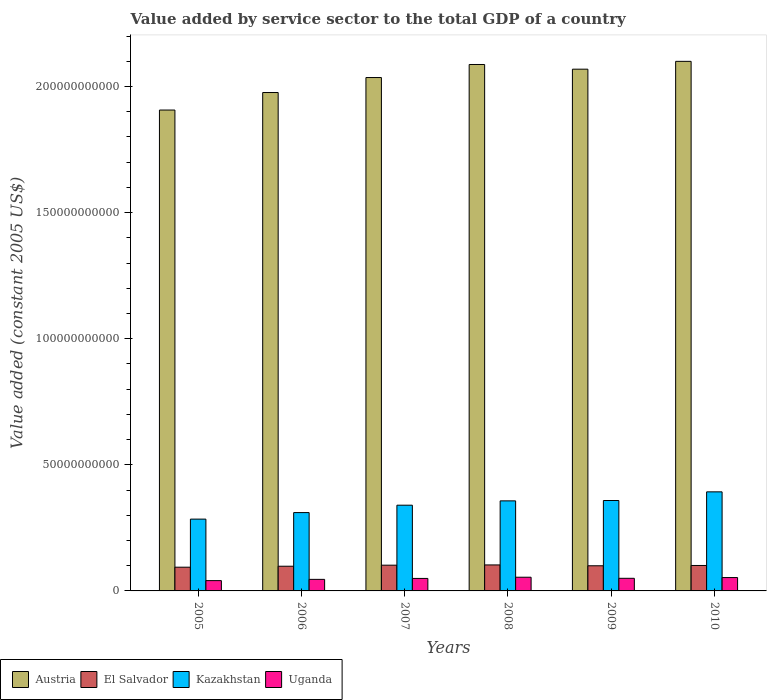What is the value added by service sector in Uganda in 2007?
Give a very brief answer. 4.95e+09. Across all years, what is the maximum value added by service sector in Austria?
Make the answer very short. 2.10e+11. Across all years, what is the minimum value added by service sector in Uganda?
Provide a short and direct response. 4.08e+09. In which year was the value added by service sector in Kazakhstan maximum?
Provide a short and direct response. 2010. What is the total value added by service sector in El Salvador in the graph?
Provide a succinct answer. 5.98e+1. What is the difference between the value added by service sector in Austria in 2005 and that in 2008?
Keep it short and to the point. -1.81e+1. What is the difference between the value added by service sector in El Salvador in 2008 and the value added by service sector in Austria in 2005?
Your answer should be compact. -1.80e+11. What is the average value added by service sector in Austria per year?
Provide a succinct answer. 2.03e+11. In the year 2009, what is the difference between the value added by service sector in El Salvador and value added by service sector in Uganda?
Make the answer very short. 4.97e+09. In how many years, is the value added by service sector in El Salvador greater than 80000000000 US$?
Provide a short and direct response. 0. What is the ratio of the value added by service sector in Kazakhstan in 2008 to that in 2009?
Make the answer very short. 1. What is the difference between the highest and the second highest value added by service sector in Austria?
Offer a very short reply. 1.24e+09. What is the difference between the highest and the lowest value added by service sector in Kazakhstan?
Keep it short and to the point. 1.08e+1. In how many years, is the value added by service sector in El Salvador greater than the average value added by service sector in El Salvador taken over all years?
Give a very brief answer. 4. Is the sum of the value added by service sector in El Salvador in 2007 and 2009 greater than the maximum value added by service sector in Uganda across all years?
Offer a terse response. Yes. What does the 2nd bar from the left in 2010 represents?
Provide a short and direct response. El Salvador. What does the 3rd bar from the right in 2006 represents?
Offer a terse response. El Salvador. Is it the case that in every year, the sum of the value added by service sector in Austria and value added by service sector in El Salvador is greater than the value added by service sector in Uganda?
Your response must be concise. Yes. How many bars are there?
Your answer should be compact. 24. Are all the bars in the graph horizontal?
Make the answer very short. No. Are the values on the major ticks of Y-axis written in scientific E-notation?
Provide a short and direct response. No. Does the graph contain any zero values?
Ensure brevity in your answer.  No. Does the graph contain grids?
Give a very brief answer. No. Where does the legend appear in the graph?
Give a very brief answer. Bottom left. How are the legend labels stacked?
Provide a succinct answer. Horizontal. What is the title of the graph?
Give a very brief answer. Value added by service sector to the total GDP of a country. What is the label or title of the Y-axis?
Your answer should be compact. Value added (constant 2005 US$). What is the Value added (constant 2005 US$) of Austria in 2005?
Offer a very short reply. 1.91e+11. What is the Value added (constant 2005 US$) of El Salvador in 2005?
Your answer should be very brief. 9.41e+09. What is the Value added (constant 2005 US$) of Kazakhstan in 2005?
Ensure brevity in your answer.  2.85e+1. What is the Value added (constant 2005 US$) of Uganda in 2005?
Make the answer very short. 4.08e+09. What is the Value added (constant 2005 US$) of Austria in 2006?
Make the answer very short. 1.98e+11. What is the Value added (constant 2005 US$) of El Salvador in 2006?
Your answer should be very brief. 9.79e+09. What is the Value added (constant 2005 US$) of Kazakhstan in 2006?
Your response must be concise. 3.11e+1. What is the Value added (constant 2005 US$) in Uganda in 2006?
Keep it short and to the point. 4.58e+09. What is the Value added (constant 2005 US$) in Austria in 2007?
Your answer should be very brief. 2.04e+11. What is the Value added (constant 2005 US$) in El Salvador in 2007?
Provide a short and direct response. 1.02e+1. What is the Value added (constant 2005 US$) in Kazakhstan in 2007?
Provide a short and direct response. 3.40e+1. What is the Value added (constant 2005 US$) in Uganda in 2007?
Your answer should be very brief. 4.95e+09. What is the Value added (constant 2005 US$) of Austria in 2008?
Offer a terse response. 2.09e+11. What is the Value added (constant 2005 US$) of El Salvador in 2008?
Provide a short and direct response. 1.03e+1. What is the Value added (constant 2005 US$) in Kazakhstan in 2008?
Your response must be concise. 3.57e+1. What is the Value added (constant 2005 US$) in Uganda in 2008?
Give a very brief answer. 5.43e+09. What is the Value added (constant 2005 US$) in Austria in 2009?
Make the answer very short. 2.07e+11. What is the Value added (constant 2005 US$) of El Salvador in 2009?
Keep it short and to the point. 9.97e+09. What is the Value added (constant 2005 US$) of Kazakhstan in 2009?
Provide a short and direct response. 3.58e+1. What is the Value added (constant 2005 US$) in Uganda in 2009?
Provide a succinct answer. 5.00e+09. What is the Value added (constant 2005 US$) of Austria in 2010?
Provide a succinct answer. 2.10e+11. What is the Value added (constant 2005 US$) in El Salvador in 2010?
Offer a very short reply. 1.01e+1. What is the Value added (constant 2005 US$) of Kazakhstan in 2010?
Your answer should be very brief. 3.93e+1. What is the Value added (constant 2005 US$) in Uganda in 2010?
Ensure brevity in your answer.  5.30e+09. Across all years, what is the maximum Value added (constant 2005 US$) in Austria?
Provide a succinct answer. 2.10e+11. Across all years, what is the maximum Value added (constant 2005 US$) in El Salvador?
Offer a terse response. 1.03e+1. Across all years, what is the maximum Value added (constant 2005 US$) in Kazakhstan?
Give a very brief answer. 3.93e+1. Across all years, what is the maximum Value added (constant 2005 US$) in Uganda?
Offer a very short reply. 5.43e+09. Across all years, what is the minimum Value added (constant 2005 US$) of Austria?
Provide a short and direct response. 1.91e+11. Across all years, what is the minimum Value added (constant 2005 US$) in El Salvador?
Your answer should be compact. 9.41e+09. Across all years, what is the minimum Value added (constant 2005 US$) of Kazakhstan?
Give a very brief answer. 2.85e+1. Across all years, what is the minimum Value added (constant 2005 US$) in Uganda?
Your answer should be compact. 4.08e+09. What is the total Value added (constant 2005 US$) of Austria in the graph?
Offer a terse response. 1.22e+12. What is the total Value added (constant 2005 US$) in El Salvador in the graph?
Give a very brief answer. 5.98e+1. What is the total Value added (constant 2005 US$) of Kazakhstan in the graph?
Your response must be concise. 2.04e+11. What is the total Value added (constant 2005 US$) of Uganda in the graph?
Your answer should be compact. 2.93e+1. What is the difference between the Value added (constant 2005 US$) in Austria in 2005 and that in 2006?
Your answer should be compact. -6.94e+09. What is the difference between the Value added (constant 2005 US$) of El Salvador in 2005 and that in 2006?
Ensure brevity in your answer.  -3.86e+08. What is the difference between the Value added (constant 2005 US$) in Kazakhstan in 2005 and that in 2006?
Your answer should be very brief. -2.59e+09. What is the difference between the Value added (constant 2005 US$) in Uganda in 2005 and that in 2006?
Ensure brevity in your answer.  -4.97e+08. What is the difference between the Value added (constant 2005 US$) of Austria in 2005 and that in 2007?
Your answer should be very brief. -1.29e+1. What is the difference between the Value added (constant 2005 US$) of El Salvador in 2005 and that in 2007?
Make the answer very short. -7.97e+08. What is the difference between the Value added (constant 2005 US$) of Kazakhstan in 2005 and that in 2007?
Offer a terse response. -5.52e+09. What is the difference between the Value added (constant 2005 US$) of Uganda in 2005 and that in 2007?
Provide a succinct answer. -8.66e+08. What is the difference between the Value added (constant 2005 US$) of Austria in 2005 and that in 2008?
Make the answer very short. -1.81e+1. What is the difference between the Value added (constant 2005 US$) of El Salvador in 2005 and that in 2008?
Ensure brevity in your answer.  -8.98e+08. What is the difference between the Value added (constant 2005 US$) in Kazakhstan in 2005 and that in 2008?
Provide a short and direct response. -7.24e+09. What is the difference between the Value added (constant 2005 US$) of Uganda in 2005 and that in 2008?
Your answer should be compact. -1.34e+09. What is the difference between the Value added (constant 2005 US$) in Austria in 2005 and that in 2009?
Provide a succinct answer. -1.62e+1. What is the difference between the Value added (constant 2005 US$) of El Salvador in 2005 and that in 2009?
Your answer should be compact. -5.64e+08. What is the difference between the Value added (constant 2005 US$) in Kazakhstan in 2005 and that in 2009?
Your response must be concise. -7.38e+09. What is the difference between the Value added (constant 2005 US$) of Uganda in 2005 and that in 2009?
Ensure brevity in your answer.  -9.18e+08. What is the difference between the Value added (constant 2005 US$) in Austria in 2005 and that in 2010?
Make the answer very short. -1.93e+1. What is the difference between the Value added (constant 2005 US$) of El Salvador in 2005 and that in 2010?
Keep it short and to the point. -6.80e+08. What is the difference between the Value added (constant 2005 US$) of Kazakhstan in 2005 and that in 2010?
Make the answer very short. -1.08e+1. What is the difference between the Value added (constant 2005 US$) of Uganda in 2005 and that in 2010?
Give a very brief answer. -1.22e+09. What is the difference between the Value added (constant 2005 US$) in Austria in 2006 and that in 2007?
Ensure brevity in your answer.  -5.94e+09. What is the difference between the Value added (constant 2005 US$) of El Salvador in 2006 and that in 2007?
Your answer should be compact. -4.12e+08. What is the difference between the Value added (constant 2005 US$) of Kazakhstan in 2006 and that in 2007?
Give a very brief answer. -2.93e+09. What is the difference between the Value added (constant 2005 US$) of Uganda in 2006 and that in 2007?
Your answer should be compact. -3.69e+08. What is the difference between the Value added (constant 2005 US$) in Austria in 2006 and that in 2008?
Provide a succinct answer. -1.11e+1. What is the difference between the Value added (constant 2005 US$) in El Salvador in 2006 and that in 2008?
Offer a terse response. -5.12e+08. What is the difference between the Value added (constant 2005 US$) of Kazakhstan in 2006 and that in 2008?
Keep it short and to the point. -4.65e+09. What is the difference between the Value added (constant 2005 US$) of Uganda in 2006 and that in 2008?
Make the answer very short. -8.47e+08. What is the difference between the Value added (constant 2005 US$) in Austria in 2006 and that in 2009?
Your answer should be compact. -9.26e+09. What is the difference between the Value added (constant 2005 US$) of El Salvador in 2006 and that in 2009?
Give a very brief answer. -1.78e+08. What is the difference between the Value added (constant 2005 US$) in Kazakhstan in 2006 and that in 2009?
Your answer should be compact. -4.79e+09. What is the difference between the Value added (constant 2005 US$) in Uganda in 2006 and that in 2009?
Your response must be concise. -4.21e+08. What is the difference between the Value added (constant 2005 US$) of Austria in 2006 and that in 2010?
Your answer should be very brief. -1.24e+1. What is the difference between the Value added (constant 2005 US$) of El Salvador in 2006 and that in 2010?
Give a very brief answer. -2.94e+08. What is the difference between the Value added (constant 2005 US$) in Kazakhstan in 2006 and that in 2010?
Offer a very short reply. -8.22e+09. What is the difference between the Value added (constant 2005 US$) of Uganda in 2006 and that in 2010?
Keep it short and to the point. -7.18e+08. What is the difference between the Value added (constant 2005 US$) of Austria in 2007 and that in 2008?
Your response must be concise. -5.18e+09. What is the difference between the Value added (constant 2005 US$) of El Salvador in 2007 and that in 2008?
Make the answer very short. -1.01e+08. What is the difference between the Value added (constant 2005 US$) of Kazakhstan in 2007 and that in 2008?
Offer a very short reply. -1.72e+09. What is the difference between the Value added (constant 2005 US$) in Uganda in 2007 and that in 2008?
Your response must be concise. -4.78e+08. What is the difference between the Value added (constant 2005 US$) of Austria in 2007 and that in 2009?
Your answer should be compact. -3.32e+09. What is the difference between the Value added (constant 2005 US$) of El Salvador in 2007 and that in 2009?
Ensure brevity in your answer.  2.33e+08. What is the difference between the Value added (constant 2005 US$) of Kazakhstan in 2007 and that in 2009?
Your answer should be compact. -1.86e+09. What is the difference between the Value added (constant 2005 US$) of Uganda in 2007 and that in 2009?
Make the answer very short. -5.24e+07. What is the difference between the Value added (constant 2005 US$) in Austria in 2007 and that in 2010?
Give a very brief answer. -6.42e+09. What is the difference between the Value added (constant 2005 US$) of El Salvador in 2007 and that in 2010?
Offer a very short reply. 1.18e+08. What is the difference between the Value added (constant 2005 US$) in Kazakhstan in 2007 and that in 2010?
Keep it short and to the point. -5.29e+09. What is the difference between the Value added (constant 2005 US$) in Uganda in 2007 and that in 2010?
Provide a short and direct response. -3.49e+08. What is the difference between the Value added (constant 2005 US$) of Austria in 2008 and that in 2009?
Give a very brief answer. 1.86e+09. What is the difference between the Value added (constant 2005 US$) in El Salvador in 2008 and that in 2009?
Your response must be concise. 3.34e+08. What is the difference between the Value added (constant 2005 US$) in Kazakhstan in 2008 and that in 2009?
Give a very brief answer. -1.38e+08. What is the difference between the Value added (constant 2005 US$) in Uganda in 2008 and that in 2009?
Provide a short and direct response. 4.26e+08. What is the difference between the Value added (constant 2005 US$) of Austria in 2008 and that in 2010?
Your answer should be very brief. -1.24e+09. What is the difference between the Value added (constant 2005 US$) in El Salvador in 2008 and that in 2010?
Your response must be concise. 2.18e+08. What is the difference between the Value added (constant 2005 US$) in Kazakhstan in 2008 and that in 2010?
Ensure brevity in your answer.  -3.57e+09. What is the difference between the Value added (constant 2005 US$) in Uganda in 2008 and that in 2010?
Offer a terse response. 1.29e+08. What is the difference between the Value added (constant 2005 US$) in Austria in 2009 and that in 2010?
Keep it short and to the point. -3.10e+09. What is the difference between the Value added (constant 2005 US$) of El Salvador in 2009 and that in 2010?
Your response must be concise. -1.16e+08. What is the difference between the Value added (constant 2005 US$) in Kazakhstan in 2009 and that in 2010?
Give a very brief answer. -3.43e+09. What is the difference between the Value added (constant 2005 US$) in Uganda in 2009 and that in 2010?
Your response must be concise. -2.97e+08. What is the difference between the Value added (constant 2005 US$) of Austria in 2005 and the Value added (constant 2005 US$) of El Salvador in 2006?
Give a very brief answer. 1.81e+11. What is the difference between the Value added (constant 2005 US$) in Austria in 2005 and the Value added (constant 2005 US$) in Kazakhstan in 2006?
Offer a terse response. 1.60e+11. What is the difference between the Value added (constant 2005 US$) in Austria in 2005 and the Value added (constant 2005 US$) in Uganda in 2006?
Ensure brevity in your answer.  1.86e+11. What is the difference between the Value added (constant 2005 US$) in El Salvador in 2005 and the Value added (constant 2005 US$) in Kazakhstan in 2006?
Make the answer very short. -2.17e+1. What is the difference between the Value added (constant 2005 US$) in El Salvador in 2005 and the Value added (constant 2005 US$) in Uganda in 2006?
Provide a short and direct response. 4.83e+09. What is the difference between the Value added (constant 2005 US$) of Kazakhstan in 2005 and the Value added (constant 2005 US$) of Uganda in 2006?
Provide a short and direct response. 2.39e+1. What is the difference between the Value added (constant 2005 US$) in Austria in 2005 and the Value added (constant 2005 US$) in El Salvador in 2007?
Your answer should be very brief. 1.80e+11. What is the difference between the Value added (constant 2005 US$) of Austria in 2005 and the Value added (constant 2005 US$) of Kazakhstan in 2007?
Give a very brief answer. 1.57e+11. What is the difference between the Value added (constant 2005 US$) of Austria in 2005 and the Value added (constant 2005 US$) of Uganda in 2007?
Provide a succinct answer. 1.86e+11. What is the difference between the Value added (constant 2005 US$) in El Salvador in 2005 and the Value added (constant 2005 US$) in Kazakhstan in 2007?
Provide a succinct answer. -2.46e+1. What is the difference between the Value added (constant 2005 US$) of El Salvador in 2005 and the Value added (constant 2005 US$) of Uganda in 2007?
Give a very brief answer. 4.46e+09. What is the difference between the Value added (constant 2005 US$) of Kazakhstan in 2005 and the Value added (constant 2005 US$) of Uganda in 2007?
Your response must be concise. 2.35e+1. What is the difference between the Value added (constant 2005 US$) in Austria in 2005 and the Value added (constant 2005 US$) in El Salvador in 2008?
Keep it short and to the point. 1.80e+11. What is the difference between the Value added (constant 2005 US$) in Austria in 2005 and the Value added (constant 2005 US$) in Kazakhstan in 2008?
Your answer should be very brief. 1.55e+11. What is the difference between the Value added (constant 2005 US$) of Austria in 2005 and the Value added (constant 2005 US$) of Uganda in 2008?
Provide a short and direct response. 1.85e+11. What is the difference between the Value added (constant 2005 US$) of El Salvador in 2005 and the Value added (constant 2005 US$) of Kazakhstan in 2008?
Ensure brevity in your answer.  -2.63e+1. What is the difference between the Value added (constant 2005 US$) in El Salvador in 2005 and the Value added (constant 2005 US$) in Uganda in 2008?
Your answer should be very brief. 3.98e+09. What is the difference between the Value added (constant 2005 US$) of Kazakhstan in 2005 and the Value added (constant 2005 US$) of Uganda in 2008?
Ensure brevity in your answer.  2.30e+1. What is the difference between the Value added (constant 2005 US$) in Austria in 2005 and the Value added (constant 2005 US$) in El Salvador in 2009?
Your answer should be compact. 1.81e+11. What is the difference between the Value added (constant 2005 US$) of Austria in 2005 and the Value added (constant 2005 US$) of Kazakhstan in 2009?
Your answer should be compact. 1.55e+11. What is the difference between the Value added (constant 2005 US$) of Austria in 2005 and the Value added (constant 2005 US$) of Uganda in 2009?
Ensure brevity in your answer.  1.86e+11. What is the difference between the Value added (constant 2005 US$) in El Salvador in 2005 and the Value added (constant 2005 US$) in Kazakhstan in 2009?
Make the answer very short. -2.64e+1. What is the difference between the Value added (constant 2005 US$) of El Salvador in 2005 and the Value added (constant 2005 US$) of Uganda in 2009?
Keep it short and to the point. 4.41e+09. What is the difference between the Value added (constant 2005 US$) in Kazakhstan in 2005 and the Value added (constant 2005 US$) in Uganda in 2009?
Provide a succinct answer. 2.35e+1. What is the difference between the Value added (constant 2005 US$) of Austria in 2005 and the Value added (constant 2005 US$) of El Salvador in 2010?
Your response must be concise. 1.81e+11. What is the difference between the Value added (constant 2005 US$) of Austria in 2005 and the Value added (constant 2005 US$) of Kazakhstan in 2010?
Provide a short and direct response. 1.51e+11. What is the difference between the Value added (constant 2005 US$) in Austria in 2005 and the Value added (constant 2005 US$) in Uganda in 2010?
Keep it short and to the point. 1.85e+11. What is the difference between the Value added (constant 2005 US$) in El Salvador in 2005 and the Value added (constant 2005 US$) in Kazakhstan in 2010?
Offer a very short reply. -2.99e+1. What is the difference between the Value added (constant 2005 US$) of El Salvador in 2005 and the Value added (constant 2005 US$) of Uganda in 2010?
Provide a succinct answer. 4.11e+09. What is the difference between the Value added (constant 2005 US$) of Kazakhstan in 2005 and the Value added (constant 2005 US$) of Uganda in 2010?
Ensure brevity in your answer.  2.32e+1. What is the difference between the Value added (constant 2005 US$) in Austria in 2006 and the Value added (constant 2005 US$) in El Salvador in 2007?
Keep it short and to the point. 1.87e+11. What is the difference between the Value added (constant 2005 US$) of Austria in 2006 and the Value added (constant 2005 US$) of Kazakhstan in 2007?
Provide a short and direct response. 1.64e+11. What is the difference between the Value added (constant 2005 US$) of Austria in 2006 and the Value added (constant 2005 US$) of Uganda in 2007?
Your answer should be very brief. 1.93e+11. What is the difference between the Value added (constant 2005 US$) in El Salvador in 2006 and the Value added (constant 2005 US$) in Kazakhstan in 2007?
Make the answer very short. -2.42e+1. What is the difference between the Value added (constant 2005 US$) in El Salvador in 2006 and the Value added (constant 2005 US$) in Uganda in 2007?
Provide a short and direct response. 4.84e+09. What is the difference between the Value added (constant 2005 US$) of Kazakhstan in 2006 and the Value added (constant 2005 US$) of Uganda in 2007?
Make the answer very short. 2.61e+1. What is the difference between the Value added (constant 2005 US$) of Austria in 2006 and the Value added (constant 2005 US$) of El Salvador in 2008?
Offer a very short reply. 1.87e+11. What is the difference between the Value added (constant 2005 US$) in Austria in 2006 and the Value added (constant 2005 US$) in Kazakhstan in 2008?
Provide a short and direct response. 1.62e+11. What is the difference between the Value added (constant 2005 US$) in Austria in 2006 and the Value added (constant 2005 US$) in Uganda in 2008?
Keep it short and to the point. 1.92e+11. What is the difference between the Value added (constant 2005 US$) in El Salvador in 2006 and the Value added (constant 2005 US$) in Kazakhstan in 2008?
Give a very brief answer. -2.59e+1. What is the difference between the Value added (constant 2005 US$) in El Salvador in 2006 and the Value added (constant 2005 US$) in Uganda in 2008?
Offer a very short reply. 4.37e+09. What is the difference between the Value added (constant 2005 US$) of Kazakhstan in 2006 and the Value added (constant 2005 US$) of Uganda in 2008?
Provide a short and direct response. 2.56e+1. What is the difference between the Value added (constant 2005 US$) of Austria in 2006 and the Value added (constant 2005 US$) of El Salvador in 2009?
Offer a very short reply. 1.88e+11. What is the difference between the Value added (constant 2005 US$) of Austria in 2006 and the Value added (constant 2005 US$) of Kazakhstan in 2009?
Your answer should be very brief. 1.62e+11. What is the difference between the Value added (constant 2005 US$) in Austria in 2006 and the Value added (constant 2005 US$) in Uganda in 2009?
Make the answer very short. 1.93e+11. What is the difference between the Value added (constant 2005 US$) in El Salvador in 2006 and the Value added (constant 2005 US$) in Kazakhstan in 2009?
Ensure brevity in your answer.  -2.61e+1. What is the difference between the Value added (constant 2005 US$) of El Salvador in 2006 and the Value added (constant 2005 US$) of Uganda in 2009?
Give a very brief answer. 4.79e+09. What is the difference between the Value added (constant 2005 US$) in Kazakhstan in 2006 and the Value added (constant 2005 US$) in Uganda in 2009?
Give a very brief answer. 2.61e+1. What is the difference between the Value added (constant 2005 US$) in Austria in 2006 and the Value added (constant 2005 US$) in El Salvador in 2010?
Provide a succinct answer. 1.88e+11. What is the difference between the Value added (constant 2005 US$) in Austria in 2006 and the Value added (constant 2005 US$) in Kazakhstan in 2010?
Ensure brevity in your answer.  1.58e+11. What is the difference between the Value added (constant 2005 US$) of Austria in 2006 and the Value added (constant 2005 US$) of Uganda in 2010?
Make the answer very short. 1.92e+11. What is the difference between the Value added (constant 2005 US$) in El Salvador in 2006 and the Value added (constant 2005 US$) in Kazakhstan in 2010?
Offer a terse response. -2.95e+1. What is the difference between the Value added (constant 2005 US$) in El Salvador in 2006 and the Value added (constant 2005 US$) in Uganda in 2010?
Your answer should be compact. 4.49e+09. What is the difference between the Value added (constant 2005 US$) of Kazakhstan in 2006 and the Value added (constant 2005 US$) of Uganda in 2010?
Make the answer very short. 2.58e+1. What is the difference between the Value added (constant 2005 US$) of Austria in 2007 and the Value added (constant 2005 US$) of El Salvador in 2008?
Ensure brevity in your answer.  1.93e+11. What is the difference between the Value added (constant 2005 US$) in Austria in 2007 and the Value added (constant 2005 US$) in Kazakhstan in 2008?
Your answer should be compact. 1.68e+11. What is the difference between the Value added (constant 2005 US$) in Austria in 2007 and the Value added (constant 2005 US$) in Uganda in 2008?
Offer a terse response. 1.98e+11. What is the difference between the Value added (constant 2005 US$) in El Salvador in 2007 and the Value added (constant 2005 US$) in Kazakhstan in 2008?
Your answer should be very brief. -2.55e+1. What is the difference between the Value added (constant 2005 US$) of El Salvador in 2007 and the Value added (constant 2005 US$) of Uganda in 2008?
Your response must be concise. 4.78e+09. What is the difference between the Value added (constant 2005 US$) in Kazakhstan in 2007 and the Value added (constant 2005 US$) in Uganda in 2008?
Make the answer very short. 2.86e+1. What is the difference between the Value added (constant 2005 US$) of Austria in 2007 and the Value added (constant 2005 US$) of El Salvador in 2009?
Provide a succinct answer. 1.94e+11. What is the difference between the Value added (constant 2005 US$) in Austria in 2007 and the Value added (constant 2005 US$) in Kazakhstan in 2009?
Provide a succinct answer. 1.68e+11. What is the difference between the Value added (constant 2005 US$) in Austria in 2007 and the Value added (constant 2005 US$) in Uganda in 2009?
Your response must be concise. 1.99e+11. What is the difference between the Value added (constant 2005 US$) of El Salvador in 2007 and the Value added (constant 2005 US$) of Kazakhstan in 2009?
Your response must be concise. -2.56e+1. What is the difference between the Value added (constant 2005 US$) of El Salvador in 2007 and the Value added (constant 2005 US$) of Uganda in 2009?
Give a very brief answer. 5.20e+09. What is the difference between the Value added (constant 2005 US$) in Kazakhstan in 2007 and the Value added (constant 2005 US$) in Uganda in 2009?
Make the answer very short. 2.90e+1. What is the difference between the Value added (constant 2005 US$) of Austria in 2007 and the Value added (constant 2005 US$) of El Salvador in 2010?
Your answer should be very brief. 1.93e+11. What is the difference between the Value added (constant 2005 US$) of Austria in 2007 and the Value added (constant 2005 US$) of Kazakhstan in 2010?
Your answer should be very brief. 1.64e+11. What is the difference between the Value added (constant 2005 US$) of Austria in 2007 and the Value added (constant 2005 US$) of Uganda in 2010?
Make the answer very short. 1.98e+11. What is the difference between the Value added (constant 2005 US$) of El Salvador in 2007 and the Value added (constant 2005 US$) of Kazakhstan in 2010?
Give a very brief answer. -2.91e+1. What is the difference between the Value added (constant 2005 US$) in El Salvador in 2007 and the Value added (constant 2005 US$) in Uganda in 2010?
Make the answer very short. 4.91e+09. What is the difference between the Value added (constant 2005 US$) in Kazakhstan in 2007 and the Value added (constant 2005 US$) in Uganda in 2010?
Offer a very short reply. 2.87e+1. What is the difference between the Value added (constant 2005 US$) of Austria in 2008 and the Value added (constant 2005 US$) of El Salvador in 2009?
Ensure brevity in your answer.  1.99e+11. What is the difference between the Value added (constant 2005 US$) of Austria in 2008 and the Value added (constant 2005 US$) of Kazakhstan in 2009?
Keep it short and to the point. 1.73e+11. What is the difference between the Value added (constant 2005 US$) in Austria in 2008 and the Value added (constant 2005 US$) in Uganda in 2009?
Offer a terse response. 2.04e+11. What is the difference between the Value added (constant 2005 US$) of El Salvador in 2008 and the Value added (constant 2005 US$) of Kazakhstan in 2009?
Provide a short and direct response. -2.55e+1. What is the difference between the Value added (constant 2005 US$) in El Salvador in 2008 and the Value added (constant 2005 US$) in Uganda in 2009?
Offer a terse response. 5.30e+09. What is the difference between the Value added (constant 2005 US$) of Kazakhstan in 2008 and the Value added (constant 2005 US$) of Uganda in 2009?
Your response must be concise. 3.07e+1. What is the difference between the Value added (constant 2005 US$) in Austria in 2008 and the Value added (constant 2005 US$) in El Salvador in 2010?
Your answer should be compact. 1.99e+11. What is the difference between the Value added (constant 2005 US$) of Austria in 2008 and the Value added (constant 2005 US$) of Kazakhstan in 2010?
Make the answer very short. 1.69e+11. What is the difference between the Value added (constant 2005 US$) in Austria in 2008 and the Value added (constant 2005 US$) in Uganda in 2010?
Provide a short and direct response. 2.03e+11. What is the difference between the Value added (constant 2005 US$) in El Salvador in 2008 and the Value added (constant 2005 US$) in Kazakhstan in 2010?
Offer a terse response. -2.90e+1. What is the difference between the Value added (constant 2005 US$) of El Salvador in 2008 and the Value added (constant 2005 US$) of Uganda in 2010?
Provide a succinct answer. 5.01e+09. What is the difference between the Value added (constant 2005 US$) in Kazakhstan in 2008 and the Value added (constant 2005 US$) in Uganda in 2010?
Offer a very short reply. 3.04e+1. What is the difference between the Value added (constant 2005 US$) in Austria in 2009 and the Value added (constant 2005 US$) in El Salvador in 2010?
Give a very brief answer. 1.97e+11. What is the difference between the Value added (constant 2005 US$) in Austria in 2009 and the Value added (constant 2005 US$) in Kazakhstan in 2010?
Provide a succinct answer. 1.68e+11. What is the difference between the Value added (constant 2005 US$) of Austria in 2009 and the Value added (constant 2005 US$) of Uganda in 2010?
Keep it short and to the point. 2.02e+11. What is the difference between the Value added (constant 2005 US$) of El Salvador in 2009 and the Value added (constant 2005 US$) of Kazakhstan in 2010?
Provide a succinct answer. -2.93e+1. What is the difference between the Value added (constant 2005 US$) in El Salvador in 2009 and the Value added (constant 2005 US$) in Uganda in 2010?
Your answer should be very brief. 4.67e+09. What is the difference between the Value added (constant 2005 US$) of Kazakhstan in 2009 and the Value added (constant 2005 US$) of Uganda in 2010?
Offer a very short reply. 3.05e+1. What is the average Value added (constant 2005 US$) of Austria per year?
Ensure brevity in your answer.  2.03e+11. What is the average Value added (constant 2005 US$) in El Salvador per year?
Your answer should be compact. 9.96e+09. What is the average Value added (constant 2005 US$) of Kazakhstan per year?
Your answer should be very brief. 3.41e+1. What is the average Value added (constant 2005 US$) in Uganda per year?
Your answer should be compact. 4.89e+09. In the year 2005, what is the difference between the Value added (constant 2005 US$) of Austria and Value added (constant 2005 US$) of El Salvador?
Provide a succinct answer. 1.81e+11. In the year 2005, what is the difference between the Value added (constant 2005 US$) of Austria and Value added (constant 2005 US$) of Kazakhstan?
Offer a very short reply. 1.62e+11. In the year 2005, what is the difference between the Value added (constant 2005 US$) of Austria and Value added (constant 2005 US$) of Uganda?
Offer a very short reply. 1.87e+11. In the year 2005, what is the difference between the Value added (constant 2005 US$) in El Salvador and Value added (constant 2005 US$) in Kazakhstan?
Make the answer very short. -1.91e+1. In the year 2005, what is the difference between the Value added (constant 2005 US$) in El Salvador and Value added (constant 2005 US$) in Uganda?
Make the answer very short. 5.32e+09. In the year 2005, what is the difference between the Value added (constant 2005 US$) in Kazakhstan and Value added (constant 2005 US$) in Uganda?
Provide a short and direct response. 2.44e+1. In the year 2006, what is the difference between the Value added (constant 2005 US$) in Austria and Value added (constant 2005 US$) in El Salvador?
Make the answer very short. 1.88e+11. In the year 2006, what is the difference between the Value added (constant 2005 US$) in Austria and Value added (constant 2005 US$) in Kazakhstan?
Make the answer very short. 1.67e+11. In the year 2006, what is the difference between the Value added (constant 2005 US$) of Austria and Value added (constant 2005 US$) of Uganda?
Keep it short and to the point. 1.93e+11. In the year 2006, what is the difference between the Value added (constant 2005 US$) in El Salvador and Value added (constant 2005 US$) in Kazakhstan?
Keep it short and to the point. -2.13e+1. In the year 2006, what is the difference between the Value added (constant 2005 US$) in El Salvador and Value added (constant 2005 US$) in Uganda?
Give a very brief answer. 5.21e+09. In the year 2006, what is the difference between the Value added (constant 2005 US$) in Kazakhstan and Value added (constant 2005 US$) in Uganda?
Your response must be concise. 2.65e+1. In the year 2007, what is the difference between the Value added (constant 2005 US$) in Austria and Value added (constant 2005 US$) in El Salvador?
Make the answer very short. 1.93e+11. In the year 2007, what is the difference between the Value added (constant 2005 US$) of Austria and Value added (constant 2005 US$) of Kazakhstan?
Give a very brief answer. 1.70e+11. In the year 2007, what is the difference between the Value added (constant 2005 US$) in Austria and Value added (constant 2005 US$) in Uganda?
Offer a very short reply. 1.99e+11. In the year 2007, what is the difference between the Value added (constant 2005 US$) of El Salvador and Value added (constant 2005 US$) of Kazakhstan?
Give a very brief answer. -2.38e+1. In the year 2007, what is the difference between the Value added (constant 2005 US$) of El Salvador and Value added (constant 2005 US$) of Uganda?
Offer a terse response. 5.26e+09. In the year 2007, what is the difference between the Value added (constant 2005 US$) of Kazakhstan and Value added (constant 2005 US$) of Uganda?
Your response must be concise. 2.90e+1. In the year 2008, what is the difference between the Value added (constant 2005 US$) in Austria and Value added (constant 2005 US$) in El Salvador?
Ensure brevity in your answer.  1.98e+11. In the year 2008, what is the difference between the Value added (constant 2005 US$) in Austria and Value added (constant 2005 US$) in Kazakhstan?
Your response must be concise. 1.73e+11. In the year 2008, what is the difference between the Value added (constant 2005 US$) in Austria and Value added (constant 2005 US$) in Uganda?
Your answer should be very brief. 2.03e+11. In the year 2008, what is the difference between the Value added (constant 2005 US$) in El Salvador and Value added (constant 2005 US$) in Kazakhstan?
Your answer should be very brief. -2.54e+1. In the year 2008, what is the difference between the Value added (constant 2005 US$) in El Salvador and Value added (constant 2005 US$) in Uganda?
Your response must be concise. 4.88e+09. In the year 2008, what is the difference between the Value added (constant 2005 US$) of Kazakhstan and Value added (constant 2005 US$) of Uganda?
Provide a succinct answer. 3.03e+1. In the year 2009, what is the difference between the Value added (constant 2005 US$) in Austria and Value added (constant 2005 US$) in El Salvador?
Keep it short and to the point. 1.97e+11. In the year 2009, what is the difference between the Value added (constant 2005 US$) of Austria and Value added (constant 2005 US$) of Kazakhstan?
Ensure brevity in your answer.  1.71e+11. In the year 2009, what is the difference between the Value added (constant 2005 US$) in Austria and Value added (constant 2005 US$) in Uganda?
Provide a short and direct response. 2.02e+11. In the year 2009, what is the difference between the Value added (constant 2005 US$) in El Salvador and Value added (constant 2005 US$) in Kazakhstan?
Provide a succinct answer. -2.59e+1. In the year 2009, what is the difference between the Value added (constant 2005 US$) of El Salvador and Value added (constant 2005 US$) of Uganda?
Provide a short and direct response. 4.97e+09. In the year 2009, what is the difference between the Value added (constant 2005 US$) of Kazakhstan and Value added (constant 2005 US$) of Uganda?
Make the answer very short. 3.08e+1. In the year 2010, what is the difference between the Value added (constant 2005 US$) of Austria and Value added (constant 2005 US$) of El Salvador?
Provide a short and direct response. 2.00e+11. In the year 2010, what is the difference between the Value added (constant 2005 US$) in Austria and Value added (constant 2005 US$) in Kazakhstan?
Your answer should be very brief. 1.71e+11. In the year 2010, what is the difference between the Value added (constant 2005 US$) of Austria and Value added (constant 2005 US$) of Uganda?
Give a very brief answer. 2.05e+11. In the year 2010, what is the difference between the Value added (constant 2005 US$) of El Salvador and Value added (constant 2005 US$) of Kazakhstan?
Ensure brevity in your answer.  -2.92e+1. In the year 2010, what is the difference between the Value added (constant 2005 US$) of El Salvador and Value added (constant 2005 US$) of Uganda?
Offer a terse response. 4.79e+09. In the year 2010, what is the difference between the Value added (constant 2005 US$) in Kazakhstan and Value added (constant 2005 US$) in Uganda?
Make the answer very short. 3.40e+1. What is the ratio of the Value added (constant 2005 US$) in Austria in 2005 to that in 2006?
Your answer should be compact. 0.96. What is the ratio of the Value added (constant 2005 US$) in El Salvador in 2005 to that in 2006?
Your answer should be compact. 0.96. What is the ratio of the Value added (constant 2005 US$) of Kazakhstan in 2005 to that in 2006?
Offer a terse response. 0.92. What is the ratio of the Value added (constant 2005 US$) of Uganda in 2005 to that in 2006?
Offer a terse response. 0.89. What is the ratio of the Value added (constant 2005 US$) of Austria in 2005 to that in 2007?
Your answer should be very brief. 0.94. What is the ratio of the Value added (constant 2005 US$) of El Salvador in 2005 to that in 2007?
Offer a very short reply. 0.92. What is the ratio of the Value added (constant 2005 US$) in Kazakhstan in 2005 to that in 2007?
Offer a terse response. 0.84. What is the ratio of the Value added (constant 2005 US$) in Uganda in 2005 to that in 2007?
Offer a terse response. 0.83. What is the ratio of the Value added (constant 2005 US$) of Austria in 2005 to that in 2008?
Your answer should be compact. 0.91. What is the ratio of the Value added (constant 2005 US$) of El Salvador in 2005 to that in 2008?
Your response must be concise. 0.91. What is the ratio of the Value added (constant 2005 US$) of Kazakhstan in 2005 to that in 2008?
Ensure brevity in your answer.  0.8. What is the ratio of the Value added (constant 2005 US$) in Uganda in 2005 to that in 2008?
Ensure brevity in your answer.  0.75. What is the ratio of the Value added (constant 2005 US$) of Austria in 2005 to that in 2009?
Offer a very short reply. 0.92. What is the ratio of the Value added (constant 2005 US$) in El Salvador in 2005 to that in 2009?
Provide a short and direct response. 0.94. What is the ratio of the Value added (constant 2005 US$) of Kazakhstan in 2005 to that in 2009?
Offer a terse response. 0.79. What is the ratio of the Value added (constant 2005 US$) of Uganda in 2005 to that in 2009?
Give a very brief answer. 0.82. What is the ratio of the Value added (constant 2005 US$) of Austria in 2005 to that in 2010?
Your answer should be compact. 0.91. What is the ratio of the Value added (constant 2005 US$) of El Salvador in 2005 to that in 2010?
Make the answer very short. 0.93. What is the ratio of the Value added (constant 2005 US$) of Kazakhstan in 2005 to that in 2010?
Make the answer very short. 0.72. What is the ratio of the Value added (constant 2005 US$) in Uganda in 2005 to that in 2010?
Your response must be concise. 0.77. What is the ratio of the Value added (constant 2005 US$) in Austria in 2006 to that in 2007?
Your answer should be compact. 0.97. What is the ratio of the Value added (constant 2005 US$) of El Salvador in 2006 to that in 2007?
Offer a terse response. 0.96. What is the ratio of the Value added (constant 2005 US$) of Kazakhstan in 2006 to that in 2007?
Keep it short and to the point. 0.91. What is the ratio of the Value added (constant 2005 US$) of Uganda in 2006 to that in 2007?
Make the answer very short. 0.93. What is the ratio of the Value added (constant 2005 US$) in Austria in 2006 to that in 2008?
Provide a succinct answer. 0.95. What is the ratio of the Value added (constant 2005 US$) in El Salvador in 2006 to that in 2008?
Keep it short and to the point. 0.95. What is the ratio of the Value added (constant 2005 US$) of Kazakhstan in 2006 to that in 2008?
Provide a short and direct response. 0.87. What is the ratio of the Value added (constant 2005 US$) of Uganda in 2006 to that in 2008?
Offer a terse response. 0.84. What is the ratio of the Value added (constant 2005 US$) of Austria in 2006 to that in 2009?
Offer a very short reply. 0.96. What is the ratio of the Value added (constant 2005 US$) of El Salvador in 2006 to that in 2009?
Give a very brief answer. 0.98. What is the ratio of the Value added (constant 2005 US$) of Kazakhstan in 2006 to that in 2009?
Provide a short and direct response. 0.87. What is the ratio of the Value added (constant 2005 US$) in Uganda in 2006 to that in 2009?
Provide a short and direct response. 0.92. What is the ratio of the Value added (constant 2005 US$) in Austria in 2006 to that in 2010?
Keep it short and to the point. 0.94. What is the ratio of the Value added (constant 2005 US$) of El Salvador in 2006 to that in 2010?
Provide a succinct answer. 0.97. What is the ratio of the Value added (constant 2005 US$) in Kazakhstan in 2006 to that in 2010?
Ensure brevity in your answer.  0.79. What is the ratio of the Value added (constant 2005 US$) in Uganda in 2006 to that in 2010?
Keep it short and to the point. 0.86. What is the ratio of the Value added (constant 2005 US$) of Austria in 2007 to that in 2008?
Make the answer very short. 0.98. What is the ratio of the Value added (constant 2005 US$) of El Salvador in 2007 to that in 2008?
Ensure brevity in your answer.  0.99. What is the ratio of the Value added (constant 2005 US$) in Kazakhstan in 2007 to that in 2008?
Offer a very short reply. 0.95. What is the ratio of the Value added (constant 2005 US$) in Uganda in 2007 to that in 2008?
Offer a terse response. 0.91. What is the ratio of the Value added (constant 2005 US$) in El Salvador in 2007 to that in 2009?
Make the answer very short. 1.02. What is the ratio of the Value added (constant 2005 US$) in Kazakhstan in 2007 to that in 2009?
Give a very brief answer. 0.95. What is the ratio of the Value added (constant 2005 US$) of Uganda in 2007 to that in 2009?
Offer a very short reply. 0.99. What is the ratio of the Value added (constant 2005 US$) of Austria in 2007 to that in 2010?
Offer a very short reply. 0.97. What is the ratio of the Value added (constant 2005 US$) of El Salvador in 2007 to that in 2010?
Ensure brevity in your answer.  1.01. What is the ratio of the Value added (constant 2005 US$) of Kazakhstan in 2007 to that in 2010?
Provide a short and direct response. 0.87. What is the ratio of the Value added (constant 2005 US$) of Uganda in 2007 to that in 2010?
Your response must be concise. 0.93. What is the ratio of the Value added (constant 2005 US$) in Austria in 2008 to that in 2009?
Your answer should be very brief. 1.01. What is the ratio of the Value added (constant 2005 US$) in El Salvador in 2008 to that in 2009?
Keep it short and to the point. 1.03. What is the ratio of the Value added (constant 2005 US$) in Kazakhstan in 2008 to that in 2009?
Make the answer very short. 1. What is the ratio of the Value added (constant 2005 US$) of Uganda in 2008 to that in 2009?
Ensure brevity in your answer.  1.09. What is the ratio of the Value added (constant 2005 US$) in El Salvador in 2008 to that in 2010?
Offer a terse response. 1.02. What is the ratio of the Value added (constant 2005 US$) of Uganda in 2008 to that in 2010?
Provide a succinct answer. 1.02. What is the ratio of the Value added (constant 2005 US$) in Austria in 2009 to that in 2010?
Make the answer very short. 0.99. What is the ratio of the Value added (constant 2005 US$) in Kazakhstan in 2009 to that in 2010?
Make the answer very short. 0.91. What is the ratio of the Value added (constant 2005 US$) in Uganda in 2009 to that in 2010?
Give a very brief answer. 0.94. What is the difference between the highest and the second highest Value added (constant 2005 US$) of Austria?
Give a very brief answer. 1.24e+09. What is the difference between the highest and the second highest Value added (constant 2005 US$) of El Salvador?
Keep it short and to the point. 1.01e+08. What is the difference between the highest and the second highest Value added (constant 2005 US$) of Kazakhstan?
Give a very brief answer. 3.43e+09. What is the difference between the highest and the second highest Value added (constant 2005 US$) of Uganda?
Offer a very short reply. 1.29e+08. What is the difference between the highest and the lowest Value added (constant 2005 US$) in Austria?
Offer a terse response. 1.93e+1. What is the difference between the highest and the lowest Value added (constant 2005 US$) in El Salvador?
Your response must be concise. 8.98e+08. What is the difference between the highest and the lowest Value added (constant 2005 US$) in Kazakhstan?
Give a very brief answer. 1.08e+1. What is the difference between the highest and the lowest Value added (constant 2005 US$) in Uganda?
Your answer should be very brief. 1.34e+09. 